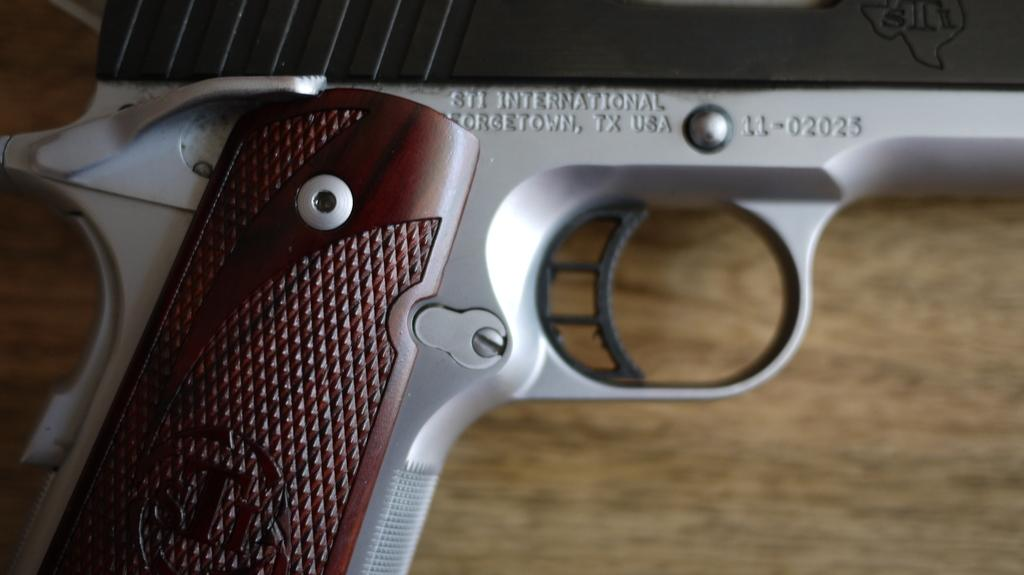What type of material is the plank in the image made of? The wooden plank in the image is made of wood. What can be seen attached to the wooden plank? A part of a gun with a handle and trigger is visible in the image. What information is written on the gun? The gun has "STI International Georgetown, TX, USA" written on it. What type of skirt is the wooden plank wearing in the image? The wooden plank is not wearing a skirt in the image; it is a plank of wood. 